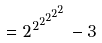<formula> <loc_0><loc_0><loc_500><loc_500>= { 2 ^ { 2 ^ { 2 ^ { 2 ^ { 2 ^ { 2 } } } } } } - 3</formula> 